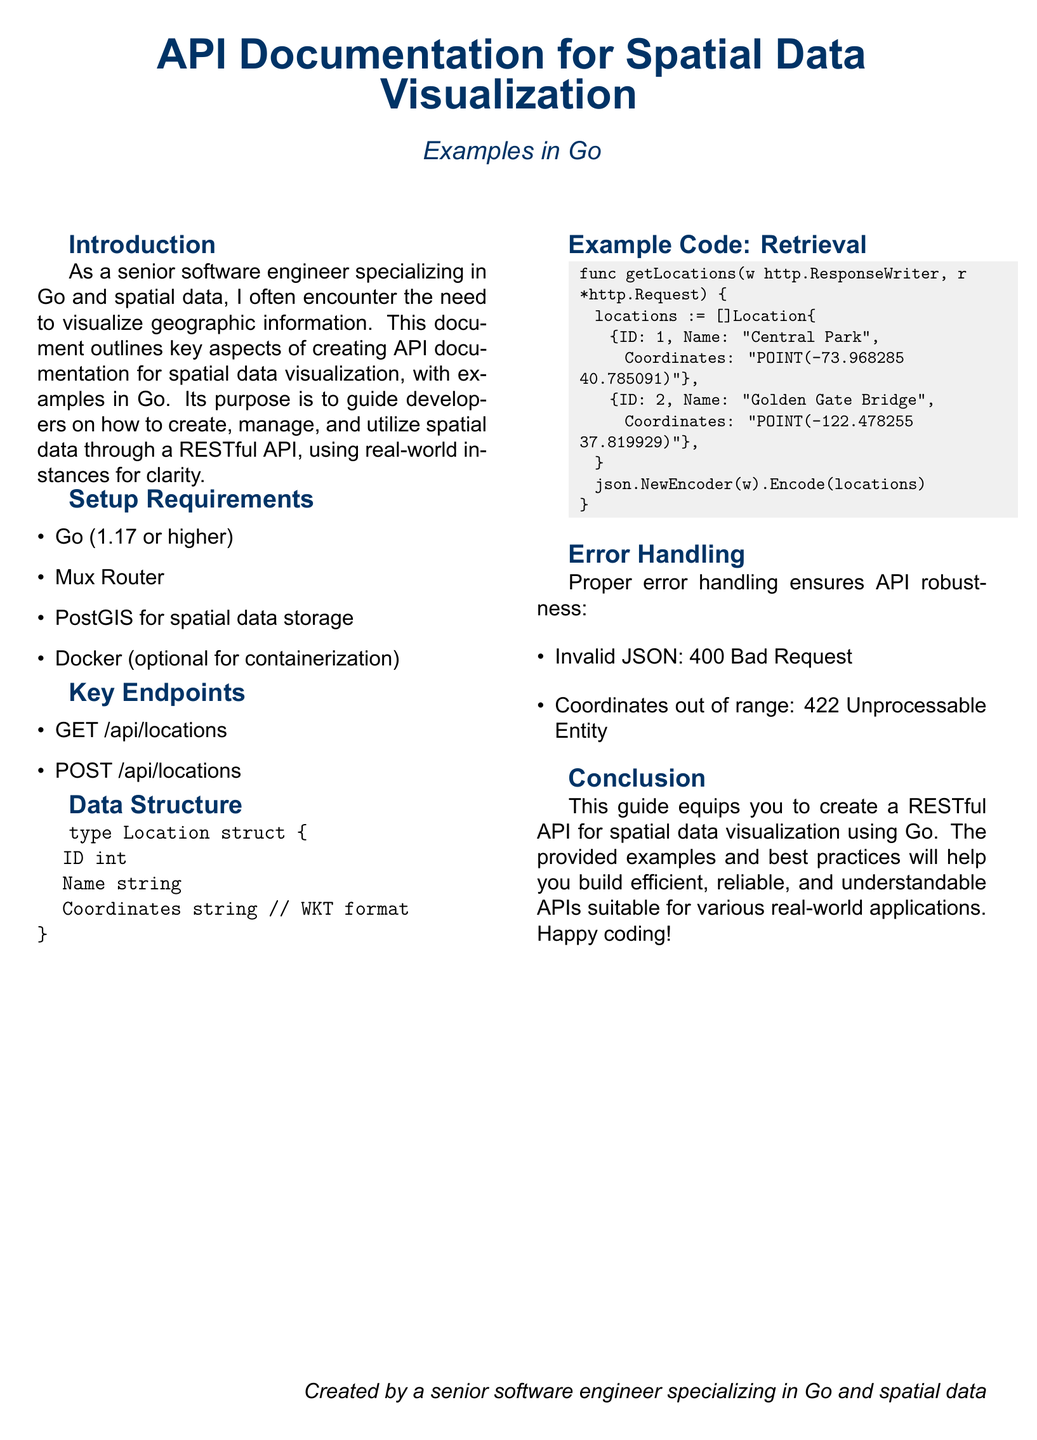What is the main topic of the document? The document discusses API documentation specifically for visualizing spatial data using Go.
Answer: API Documentation for Spatial Data Visualization What is the font used in the document? The document uses Arial as its main font as specified in the code.
Answer: Arial Which Go version is required? The document states that Go version 1.17 or higher is necessary for the setup.
Answer: 1.17 or higher What data structure is defined in the document? The document defines a Location data structure for holding spatial data.
Answer: Location What is the endpoint for retrieving locations? The document lists the GET endpoint to fetch locations as one of the key endpoints.
Answer: GET /api/locations What response code is given for invalid JSON? The document mentions a specific error response code for handling invalid JSON requests.
Answer: 400 Bad Request Which database is recommended for spatial data storage? The document indicates the recommended database for storing spatial data in the API setup requirements.
Answer: PostGIS What is contained in the Coordinates field of the Location struct? The document specifies the format for storing coordinates in the Location struct.
Answer: WKT format What is a primary outcome intended by this guide? The document outlines a straightforward goal for developers utilizing the guidance provided.
Answer: Create a RESTful API 